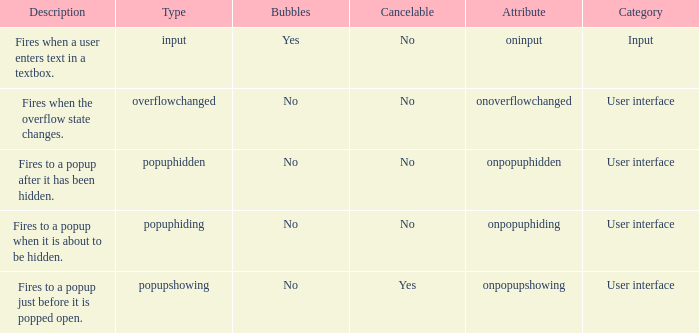What's the cancelable with bubbles being yes No. 